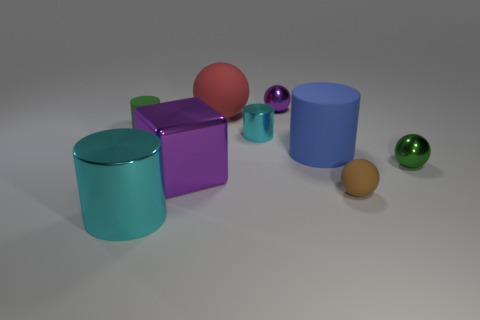There is a cyan object that is behind the blue cylinder; is there a tiny cyan cylinder behind it?
Offer a terse response. No. How many big brown cylinders are there?
Provide a succinct answer. 0. Do the cube and the tiny object behind the big ball have the same color?
Make the answer very short. Yes. Are there more tiny spheres than tiny brown matte objects?
Make the answer very short. Yes. Is there any other thing that is the same color as the large sphere?
Give a very brief answer. No. How many other things are the same size as the brown matte sphere?
Give a very brief answer. 4. There is a small green object right of the tiny thing on the left side of the metallic cylinder to the right of the big cube; what is its material?
Provide a short and direct response. Metal. Is the material of the tiny purple ball the same as the tiny thing that is on the left side of the big ball?
Your response must be concise. No. Is the number of shiny cylinders that are to the left of the big red thing less than the number of tiny purple metal things that are in front of the green shiny object?
Your answer should be very brief. No. What number of tiny cylinders are made of the same material as the large blue object?
Offer a very short reply. 1. 